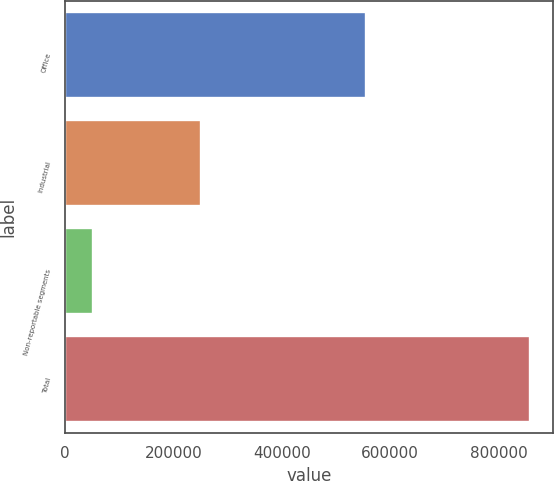<chart> <loc_0><loc_0><loc_500><loc_500><bar_chart><fcel>Office<fcel>Industrial<fcel>Non-reportable segments<fcel>Total<nl><fcel>555592<fcel>250078<fcel>51889<fcel>857559<nl></chart> 